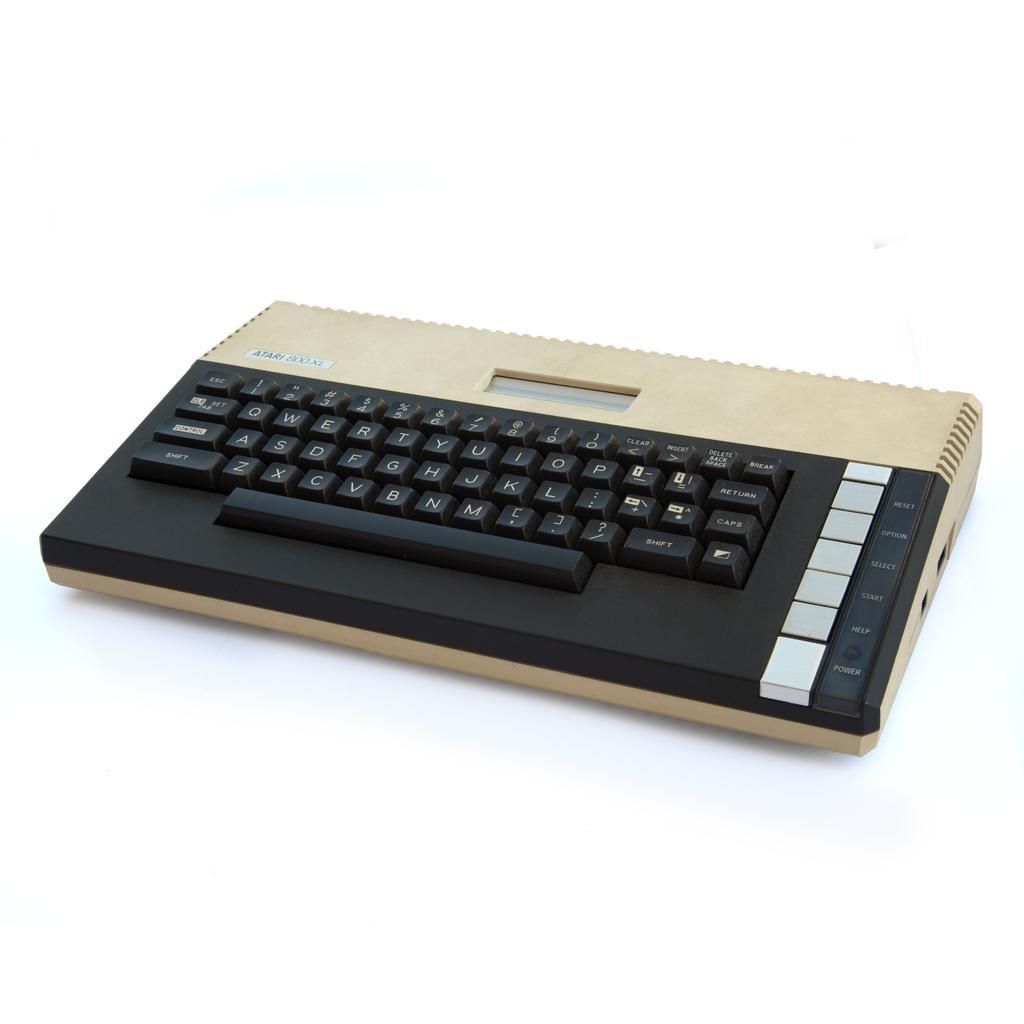<image>
Give a short and clear explanation of the subsequent image. The Atari 800 XL console is tan and black. 